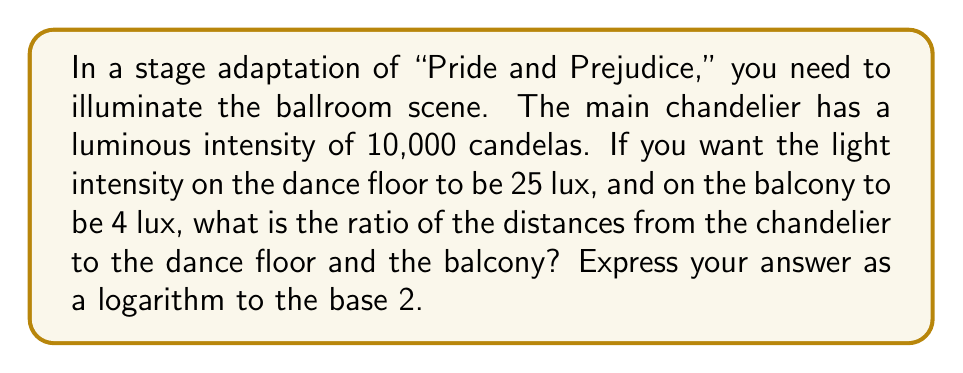Provide a solution to this math problem. Let's approach this step-by-step using the inverse square law and logarithms:

1) The inverse square law states that the intensity of light is inversely proportional to the square of the distance from the source. We can express this as:

   $$ I = \frac{k}{d^2} $$

   where $I$ is the intensity, $k$ is a constant, and $d$ is the distance.

2) Let $d_1$ be the distance to the dance floor and $d_2$ be the distance to the balcony. We can write two equations:

   $$ 25 = \frac{10000}{d_1^2} \quad \text{and} \quad 4 = \frac{10000}{d_2^2} $$

3) Solving for $d_1$ and $d_2$:

   $$ d_1^2 = \frac{10000}{25} = 400 \quad \text{and} \quad d_2^2 = \frac{10000}{4} = 2500 $$

   $$ d_1 = 20 \quad \text{and} \quad d_2 = 50 $$

4) The ratio of these distances is:

   $$ \frac{d_2}{d_1} = \frac{50}{20} = 2.5 $$

5) To express this as a logarithm to base 2, we need to find $x$ such that:

   $$ 2^x = 2.5 $$

6) Taking the logarithm of both sides:

   $$ \log_2(2^x) = \log_2(2.5) $$
   $$ x = \log_2(2.5) $$

This is our final answer.
Answer: $\log_2(2.5)$ 